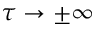<formula> <loc_0><loc_0><loc_500><loc_500>\tau \to \pm \infty</formula> 